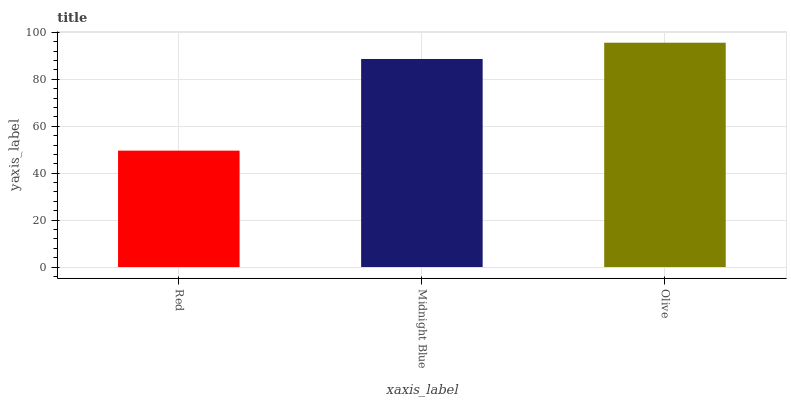Is Red the minimum?
Answer yes or no. Yes. Is Olive the maximum?
Answer yes or no. Yes. Is Midnight Blue the minimum?
Answer yes or no. No. Is Midnight Blue the maximum?
Answer yes or no. No. Is Midnight Blue greater than Red?
Answer yes or no. Yes. Is Red less than Midnight Blue?
Answer yes or no. Yes. Is Red greater than Midnight Blue?
Answer yes or no. No. Is Midnight Blue less than Red?
Answer yes or no. No. Is Midnight Blue the high median?
Answer yes or no. Yes. Is Midnight Blue the low median?
Answer yes or no. Yes. Is Olive the high median?
Answer yes or no. No. Is Red the low median?
Answer yes or no. No. 